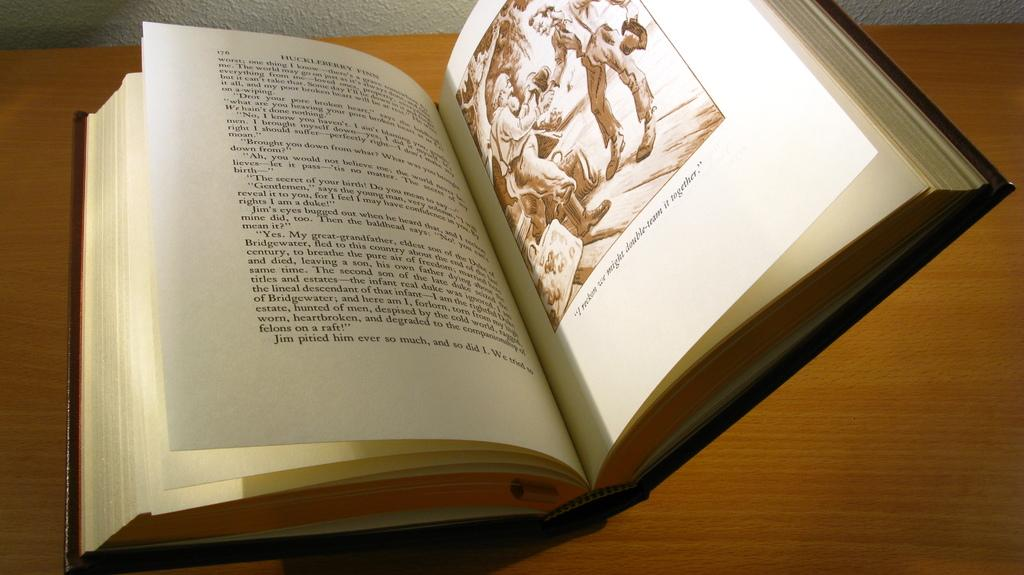What object is placed on the table in the image? There is a book placed on a table in the image. How many heads are visible in the image? There are no heads visible in the image; it only features a book placed on a table. What type of self-help book is the book in the image? The image does not provide any information about the content or genre of the book, so it cannot be determined if it is a self-help book or not. 